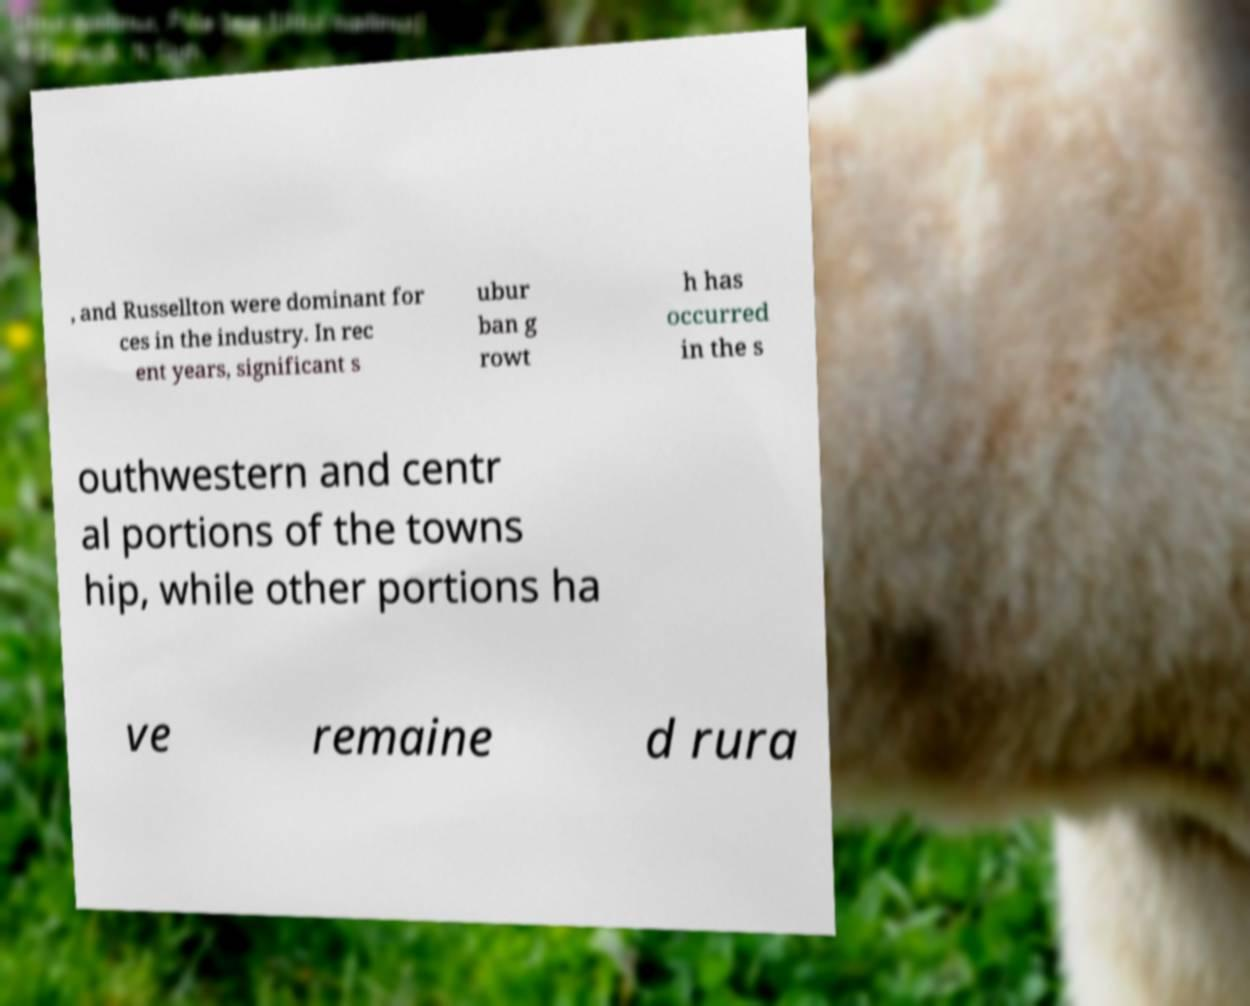Can you read and provide the text displayed in the image?This photo seems to have some interesting text. Can you extract and type it out for me? , and Russellton were dominant for ces in the industry. In rec ent years, significant s ubur ban g rowt h has occurred in the s outhwestern and centr al portions of the towns hip, while other portions ha ve remaine d rura 